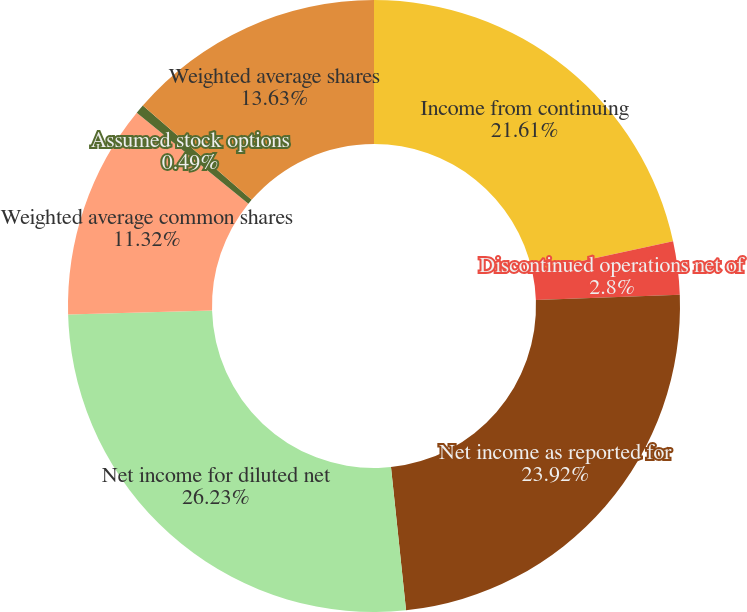<chart> <loc_0><loc_0><loc_500><loc_500><pie_chart><fcel>Income from continuing<fcel>Discontinued operations net of<fcel>Net income as reported for<fcel>Net income for diluted net<fcel>Weighted average common shares<fcel>Assumed stock options<fcel>Weighted average shares<nl><fcel>21.61%<fcel>2.8%<fcel>23.92%<fcel>26.23%<fcel>11.32%<fcel>0.49%<fcel>13.63%<nl></chart> 